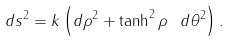<formula> <loc_0><loc_0><loc_500><loc_500>d s ^ { 2 } = k \left ( d \rho ^ { 2 } + \tanh ^ { 2 } \rho \ d \theta ^ { 2 } \right ) .</formula> 